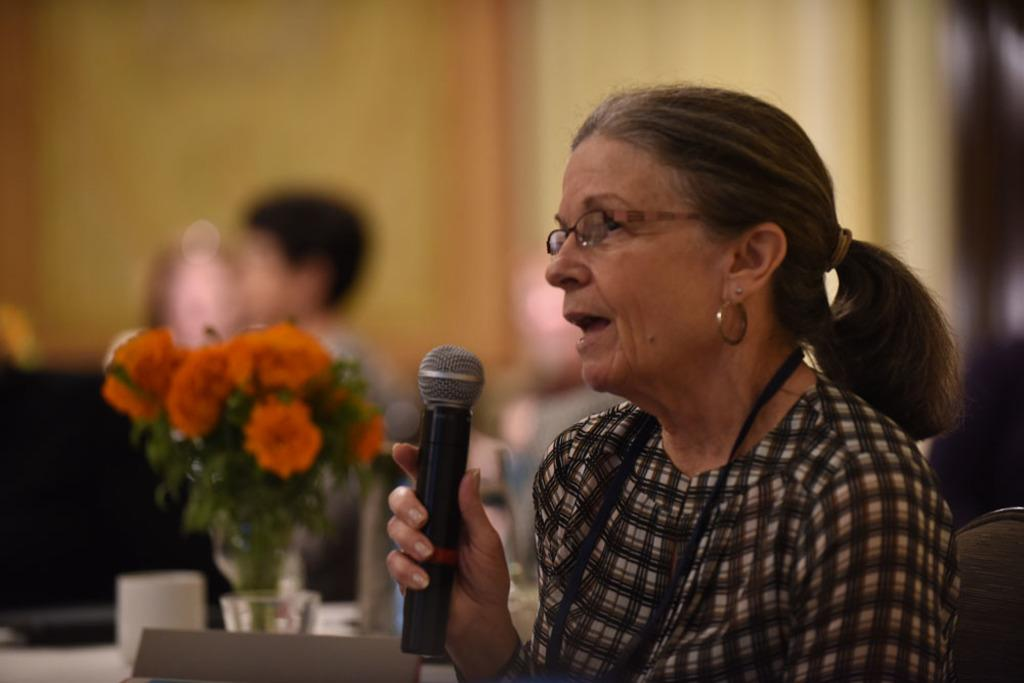Who is the main subject in the image? There is a woman in the image. What is the woman holding in her hand? The woman is holding a microphone in her hand. Can you describe the woman's appearance? The woman is wearing glasses. What is placed in front of the woman? There is a flower book in front of the woman. What other object can be seen in the image? There is a glass on a table in the image. What is the process of the woman surprising the glass in the image? There is no process of the woman surprising the glass in the image. The glass is simply on the table, and there is no indication of any surprise or smashing. 